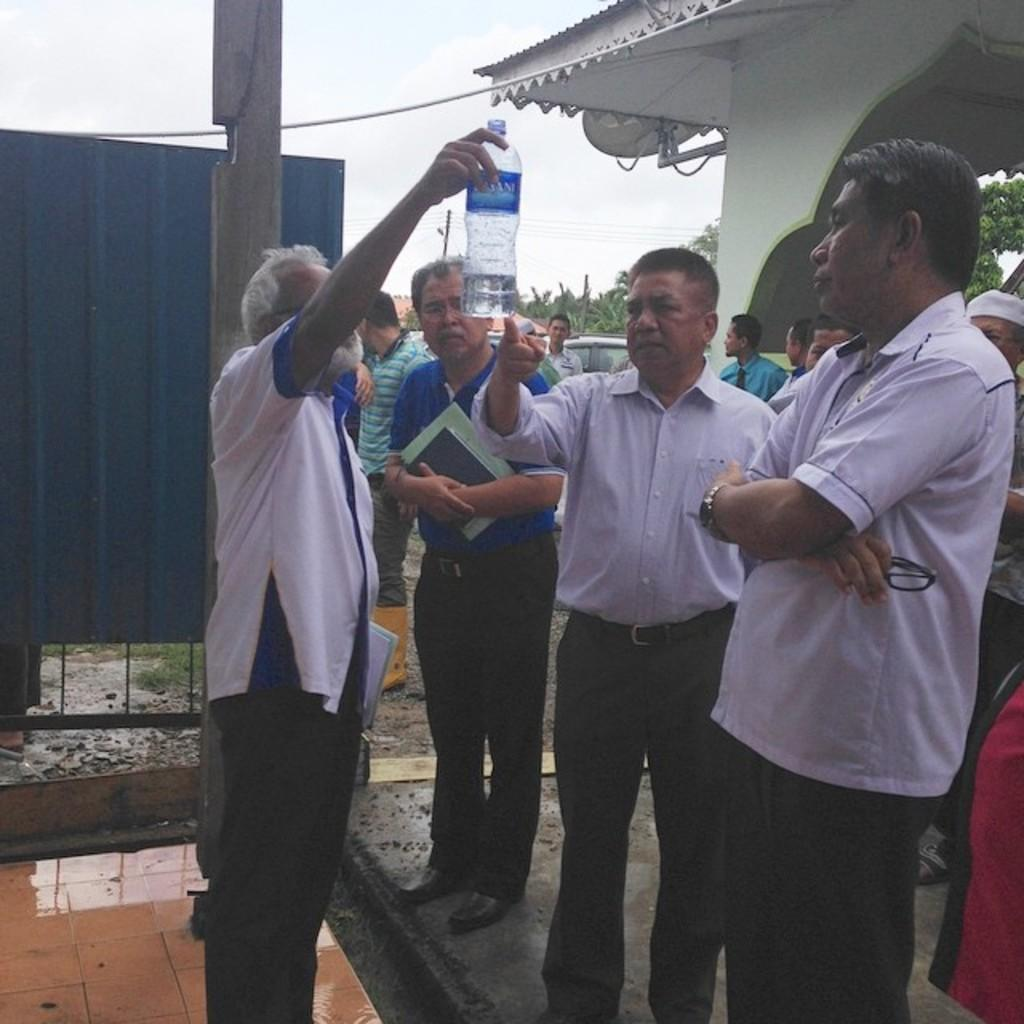What are the men in the image doing? The men are standing in the image and looking at a bottle. What can be seen in the background of the image? There are trees, a pole, the sky, and vehicles visible in the background. What is hanging on the wall in the image? A dish TV is hanging on the wall in the image. How does the society react to the men's actions in the image? The image does not provide any information about the society's reaction to the men's actions. Can you tell me how many times the men cry in the image? There is no indication in the image that the men are crying, so it cannot be determined from the image. 